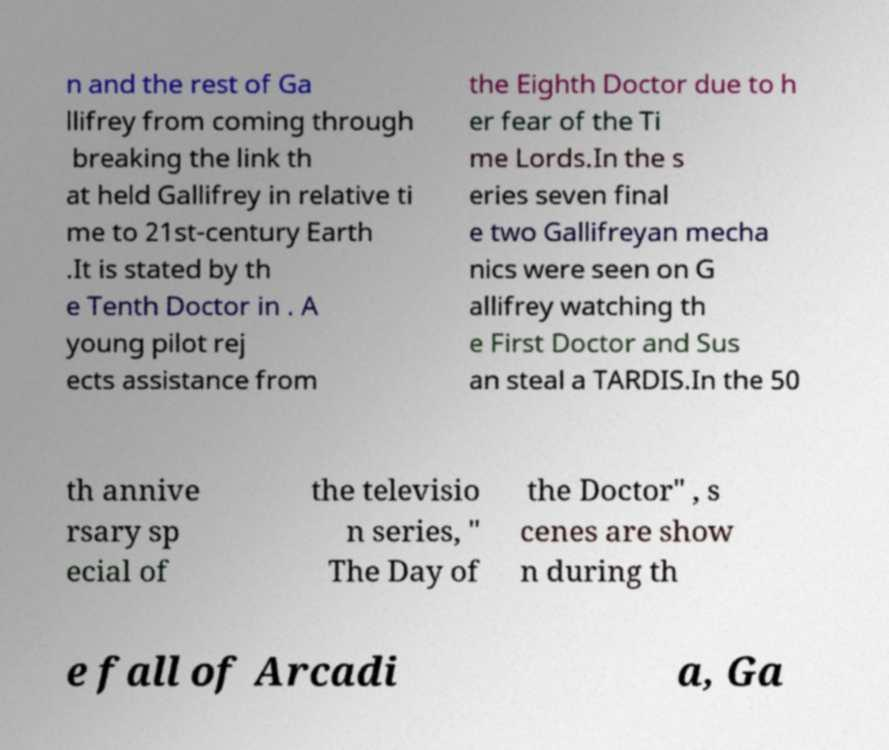Please read and relay the text visible in this image. What does it say? n and the rest of Ga llifrey from coming through breaking the link th at held Gallifrey in relative ti me to 21st-century Earth .It is stated by th e Tenth Doctor in . A young pilot rej ects assistance from the Eighth Doctor due to h er fear of the Ti me Lords.In the s eries seven final e two Gallifreyan mecha nics were seen on G allifrey watching th e First Doctor and Sus an steal a TARDIS.In the 50 th annive rsary sp ecial of the televisio n series, " The Day of the Doctor" , s cenes are show n during th e fall of Arcadi a, Ga 